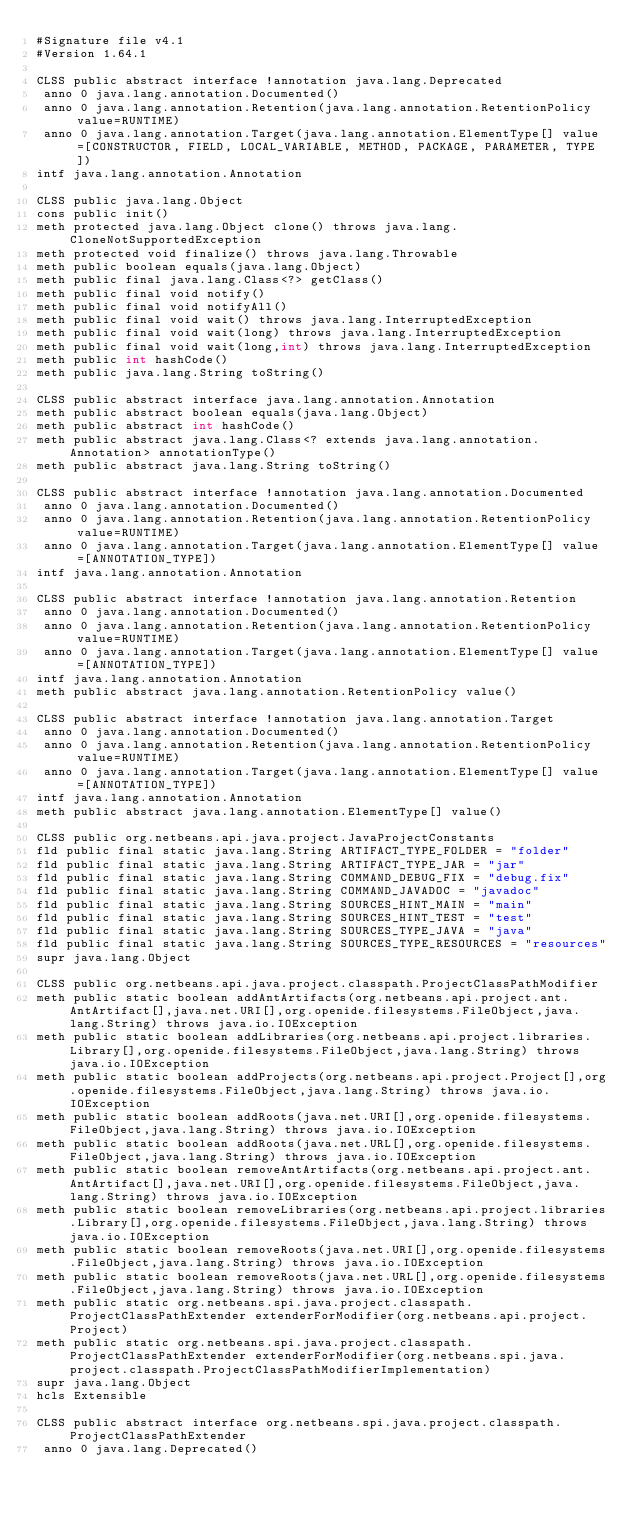Convert code to text. <code><loc_0><loc_0><loc_500><loc_500><_SML_>#Signature file v4.1
#Version 1.64.1

CLSS public abstract interface !annotation java.lang.Deprecated
 anno 0 java.lang.annotation.Documented()
 anno 0 java.lang.annotation.Retention(java.lang.annotation.RetentionPolicy value=RUNTIME)
 anno 0 java.lang.annotation.Target(java.lang.annotation.ElementType[] value=[CONSTRUCTOR, FIELD, LOCAL_VARIABLE, METHOD, PACKAGE, PARAMETER, TYPE])
intf java.lang.annotation.Annotation

CLSS public java.lang.Object
cons public init()
meth protected java.lang.Object clone() throws java.lang.CloneNotSupportedException
meth protected void finalize() throws java.lang.Throwable
meth public boolean equals(java.lang.Object)
meth public final java.lang.Class<?> getClass()
meth public final void notify()
meth public final void notifyAll()
meth public final void wait() throws java.lang.InterruptedException
meth public final void wait(long) throws java.lang.InterruptedException
meth public final void wait(long,int) throws java.lang.InterruptedException
meth public int hashCode()
meth public java.lang.String toString()

CLSS public abstract interface java.lang.annotation.Annotation
meth public abstract boolean equals(java.lang.Object)
meth public abstract int hashCode()
meth public abstract java.lang.Class<? extends java.lang.annotation.Annotation> annotationType()
meth public abstract java.lang.String toString()

CLSS public abstract interface !annotation java.lang.annotation.Documented
 anno 0 java.lang.annotation.Documented()
 anno 0 java.lang.annotation.Retention(java.lang.annotation.RetentionPolicy value=RUNTIME)
 anno 0 java.lang.annotation.Target(java.lang.annotation.ElementType[] value=[ANNOTATION_TYPE])
intf java.lang.annotation.Annotation

CLSS public abstract interface !annotation java.lang.annotation.Retention
 anno 0 java.lang.annotation.Documented()
 anno 0 java.lang.annotation.Retention(java.lang.annotation.RetentionPolicy value=RUNTIME)
 anno 0 java.lang.annotation.Target(java.lang.annotation.ElementType[] value=[ANNOTATION_TYPE])
intf java.lang.annotation.Annotation
meth public abstract java.lang.annotation.RetentionPolicy value()

CLSS public abstract interface !annotation java.lang.annotation.Target
 anno 0 java.lang.annotation.Documented()
 anno 0 java.lang.annotation.Retention(java.lang.annotation.RetentionPolicy value=RUNTIME)
 anno 0 java.lang.annotation.Target(java.lang.annotation.ElementType[] value=[ANNOTATION_TYPE])
intf java.lang.annotation.Annotation
meth public abstract java.lang.annotation.ElementType[] value()

CLSS public org.netbeans.api.java.project.JavaProjectConstants
fld public final static java.lang.String ARTIFACT_TYPE_FOLDER = "folder"
fld public final static java.lang.String ARTIFACT_TYPE_JAR = "jar"
fld public final static java.lang.String COMMAND_DEBUG_FIX = "debug.fix"
fld public final static java.lang.String COMMAND_JAVADOC = "javadoc"
fld public final static java.lang.String SOURCES_HINT_MAIN = "main"
fld public final static java.lang.String SOURCES_HINT_TEST = "test"
fld public final static java.lang.String SOURCES_TYPE_JAVA = "java"
fld public final static java.lang.String SOURCES_TYPE_RESOURCES = "resources"
supr java.lang.Object

CLSS public org.netbeans.api.java.project.classpath.ProjectClassPathModifier
meth public static boolean addAntArtifacts(org.netbeans.api.project.ant.AntArtifact[],java.net.URI[],org.openide.filesystems.FileObject,java.lang.String) throws java.io.IOException
meth public static boolean addLibraries(org.netbeans.api.project.libraries.Library[],org.openide.filesystems.FileObject,java.lang.String) throws java.io.IOException
meth public static boolean addProjects(org.netbeans.api.project.Project[],org.openide.filesystems.FileObject,java.lang.String) throws java.io.IOException
meth public static boolean addRoots(java.net.URI[],org.openide.filesystems.FileObject,java.lang.String) throws java.io.IOException
meth public static boolean addRoots(java.net.URL[],org.openide.filesystems.FileObject,java.lang.String) throws java.io.IOException
meth public static boolean removeAntArtifacts(org.netbeans.api.project.ant.AntArtifact[],java.net.URI[],org.openide.filesystems.FileObject,java.lang.String) throws java.io.IOException
meth public static boolean removeLibraries(org.netbeans.api.project.libraries.Library[],org.openide.filesystems.FileObject,java.lang.String) throws java.io.IOException
meth public static boolean removeRoots(java.net.URI[],org.openide.filesystems.FileObject,java.lang.String) throws java.io.IOException
meth public static boolean removeRoots(java.net.URL[],org.openide.filesystems.FileObject,java.lang.String) throws java.io.IOException
meth public static org.netbeans.spi.java.project.classpath.ProjectClassPathExtender extenderForModifier(org.netbeans.api.project.Project)
meth public static org.netbeans.spi.java.project.classpath.ProjectClassPathExtender extenderForModifier(org.netbeans.spi.java.project.classpath.ProjectClassPathModifierImplementation)
supr java.lang.Object
hcls Extensible

CLSS public abstract interface org.netbeans.spi.java.project.classpath.ProjectClassPathExtender
 anno 0 java.lang.Deprecated()</code> 